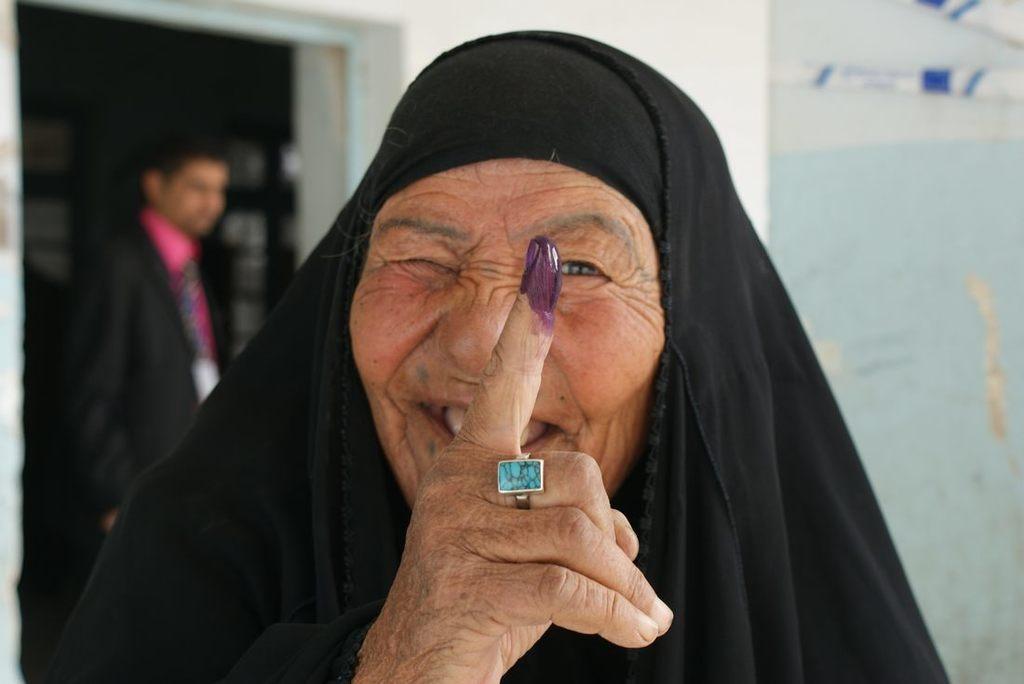In one or two sentences, can you explain what this image depicts? In this picture I can observe an old woman wearing black color dress. On the left side I can observe a person. In the background there is a wall. 